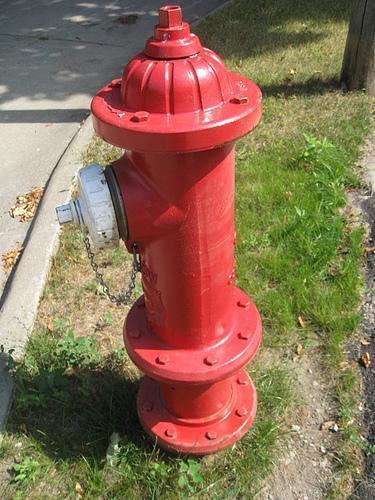How many fire hydrants are there?
Give a very brief answer. 1. How many motorcycles are there?
Give a very brief answer. 0. 